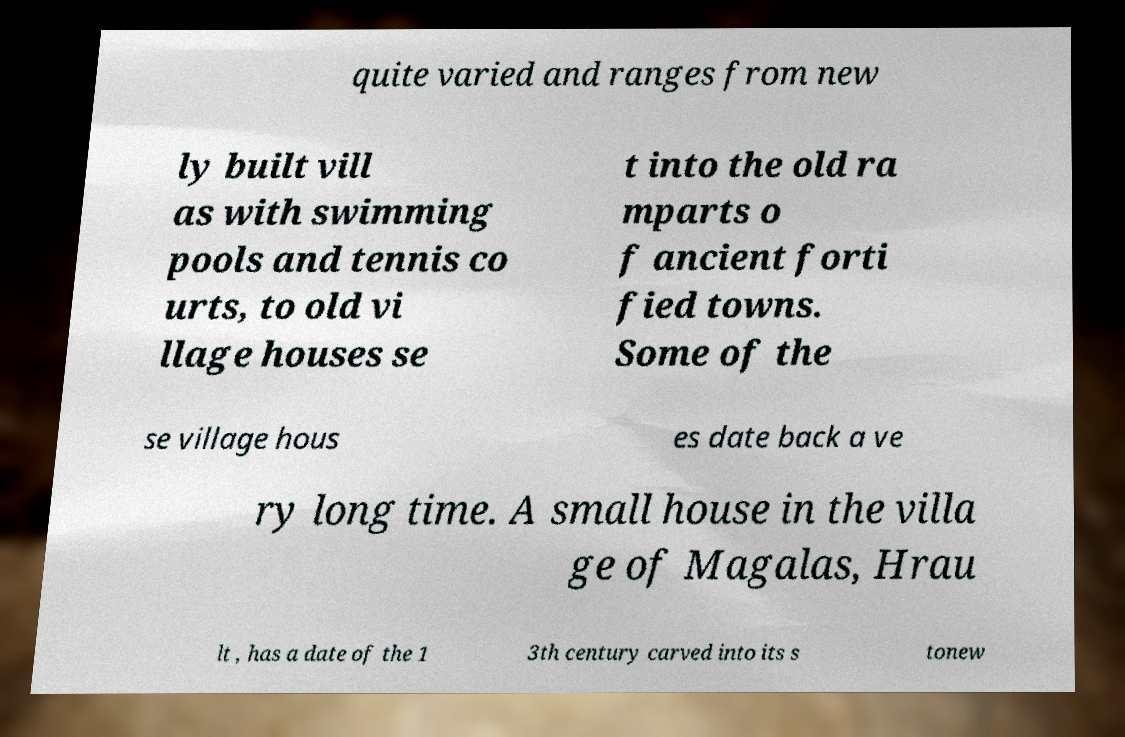Could you assist in decoding the text presented in this image and type it out clearly? quite varied and ranges from new ly built vill as with swimming pools and tennis co urts, to old vi llage houses se t into the old ra mparts o f ancient forti fied towns. Some of the se village hous es date back a ve ry long time. A small house in the villa ge of Magalas, Hrau lt , has a date of the 1 3th century carved into its s tonew 